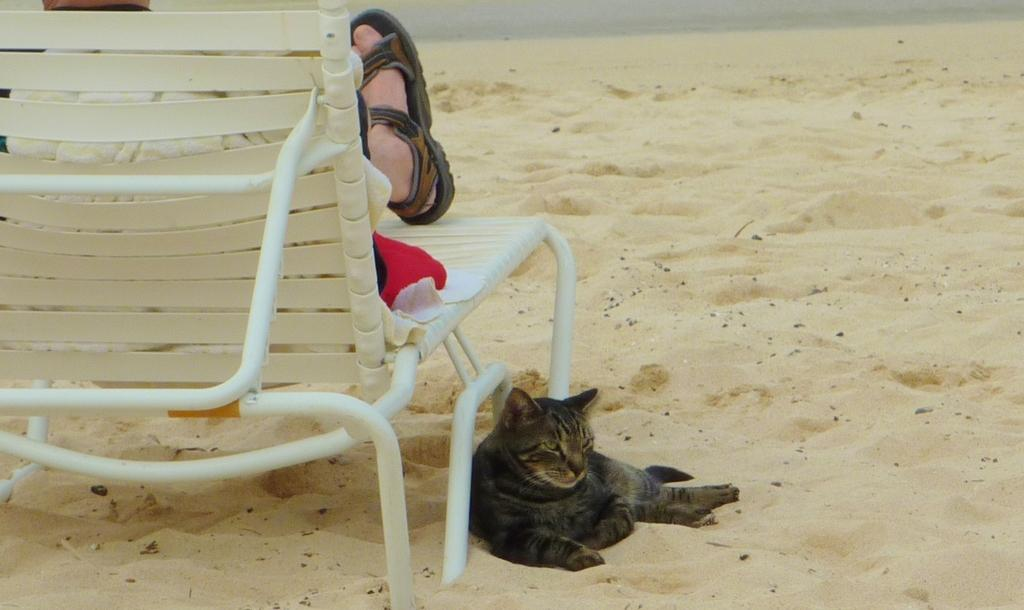What is the person in the image doing? The person is sitting on a rest chair in the image. What type of footwear is the person wearing? The person is wearing sandals. What type of clothing is the person wearing? The person is wearing clothes. What type of terrain can be seen in the image? There is sand visible in the image. Are there any animals present in the image? Yes, there is a cat in the image. What type of boot is the yak wearing in the image? There is no yak or boot present in the image. How many clams can be seen in the image? There are no clams present in the image. 